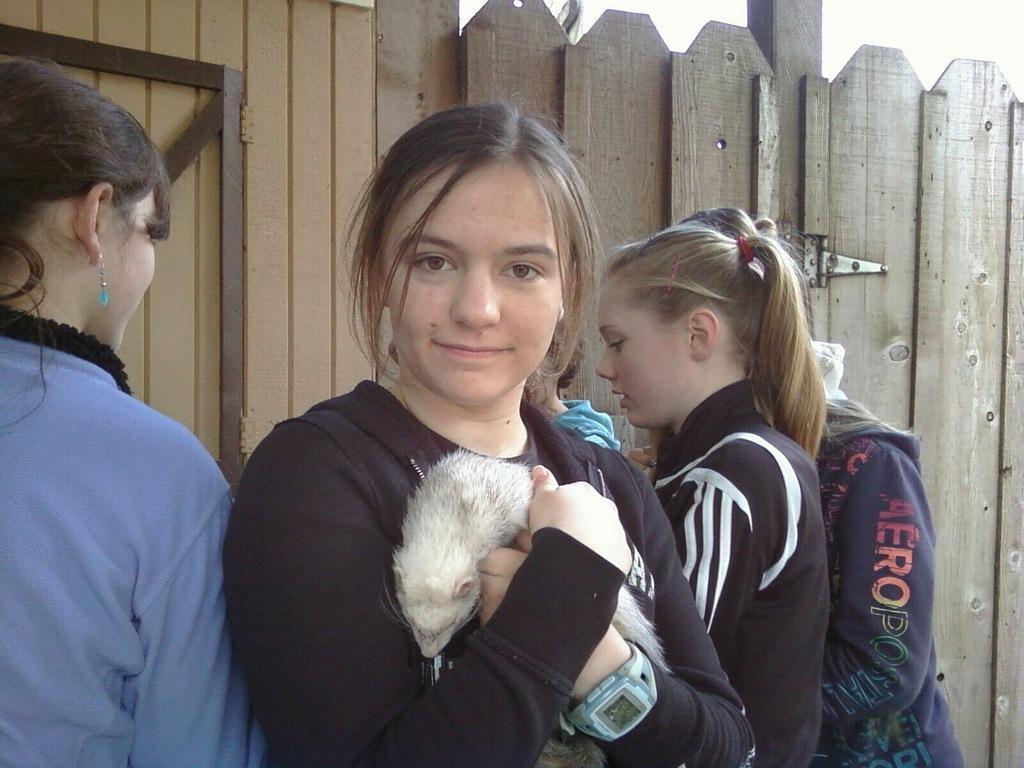Describe this image in one or two sentences. In this image we can see a few persons, among them one person is holding an animal, in the background we can see the wall and metal rods. 